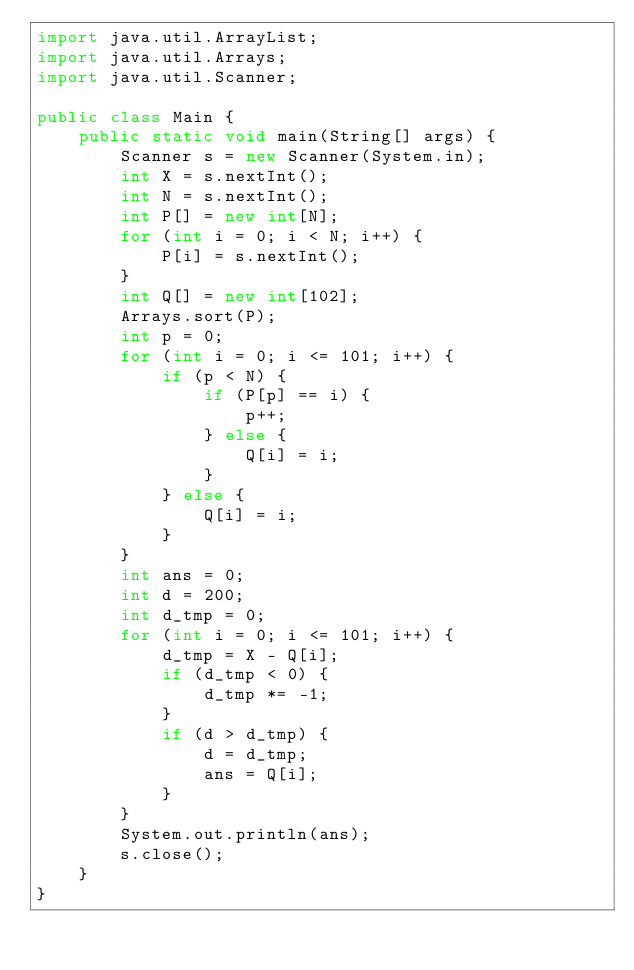<code> <loc_0><loc_0><loc_500><loc_500><_Java_>import java.util.ArrayList;
import java.util.Arrays;
import java.util.Scanner;

public class Main {
    public static void main(String[] args) {
        Scanner s = new Scanner(System.in);
        int X = s.nextInt();
        int N = s.nextInt();
        int P[] = new int[N];
        for (int i = 0; i < N; i++) {
            P[i] = s.nextInt();
        }
        int Q[] = new int[102];
        Arrays.sort(P);
        int p = 0;
        for (int i = 0; i <= 101; i++) {
            if (p < N) {
                if (P[p] == i) {
                    p++;
                } else {
                    Q[i] = i;
                }
            } else {
                Q[i] = i;
            }
        }
        int ans = 0;
        int d = 200;
        int d_tmp = 0;
        for (int i = 0; i <= 101; i++) {
            d_tmp = X - Q[i];
            if (d_tmp < 0) {
                d_tmp *= -1;
            }
            if (d > d_tmp) {
                d = d_tmp;
                ans = Q[i];
            }
        }
        System.out.println(ans);
        s.close();
    }
}</code> 